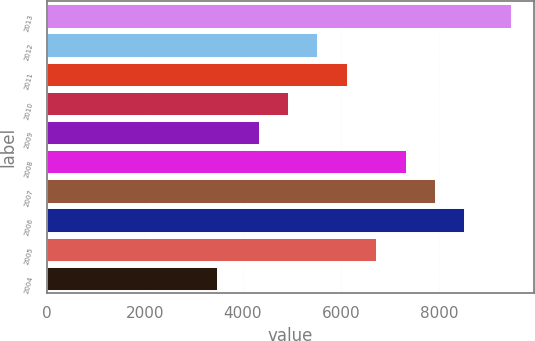<chart> <loc_0><loc_0><loc_500><loc_500><bar_chart><fcel>2013<fcel>2012<fcel>2011<fcel>2010<fcel>2009<fcel>2008<fcel>2007<fcel>2006<fcel>2005<fcel>2004<nl><fcel>9467<fcel>5518.8<fcel>6118.2<fcel>4919.4<fcel>4320<fcel>7317<fcel>7916.4<fcel>8515.8<fcel>6717.6<fcel>3473<nl></chart> 